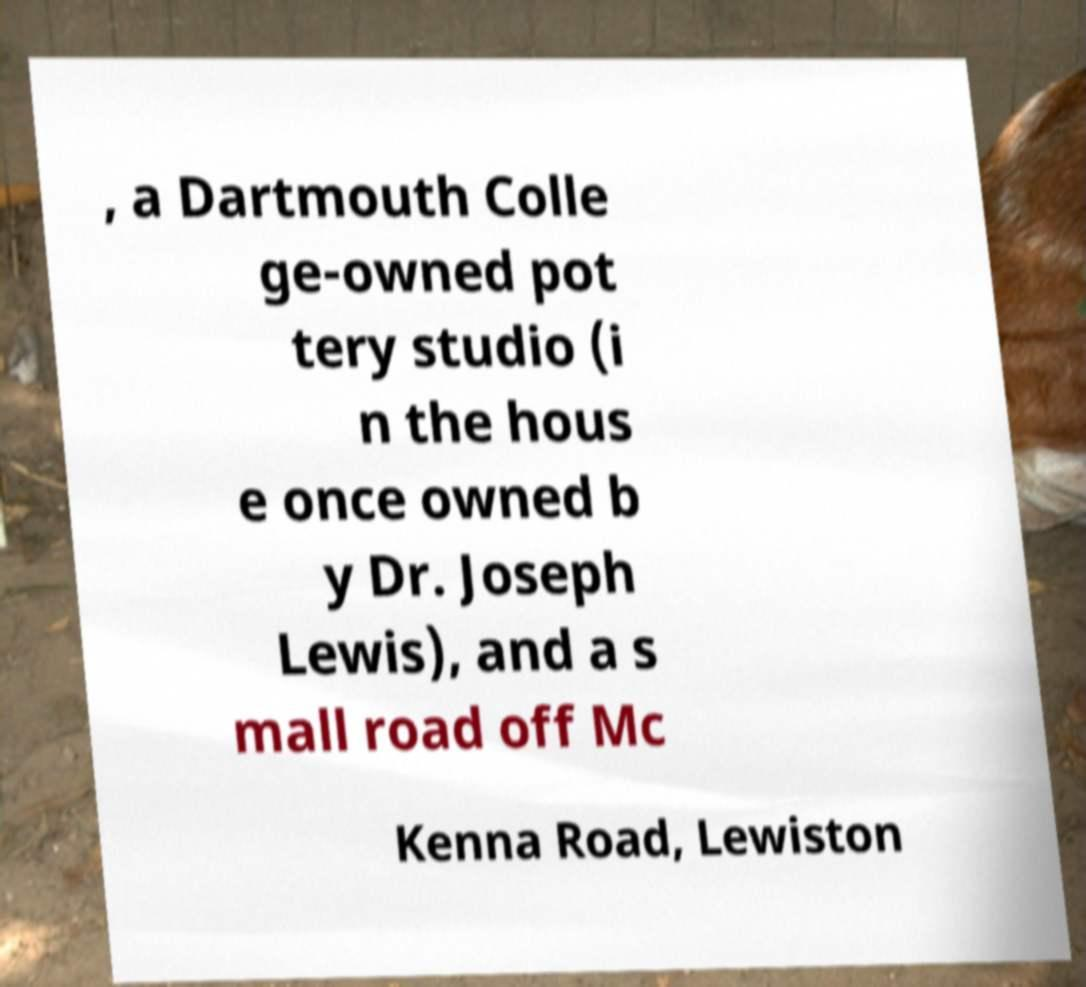For documentation purposes, I need the text within this image transcribed. Could you provide that? , a Dartmouth Colle ge-owned pot tery studio (i n the hous e once owned b y Dr. Joseph Lewis), and a s mall road off Mc Kenna Road, Lewiston 